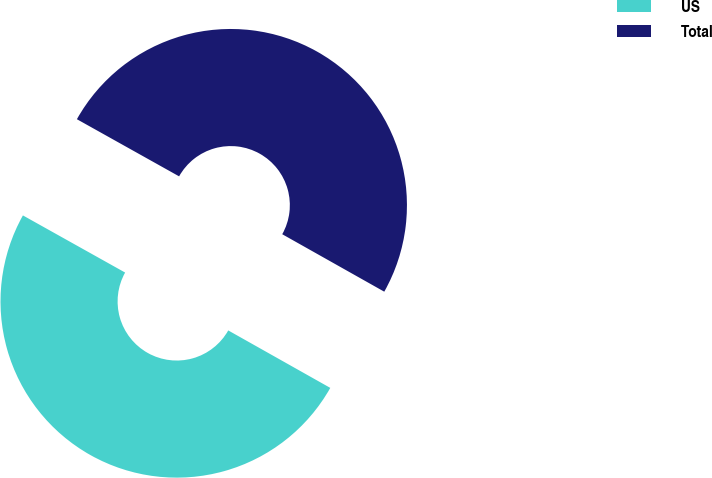Convert chart. <chart><loc_0><loc_0><loc_500><loc_500><pie_chart><fcel>US<fcel>Total<nl><fcel>49.95%<fcel>50.05%<nl></chart> 